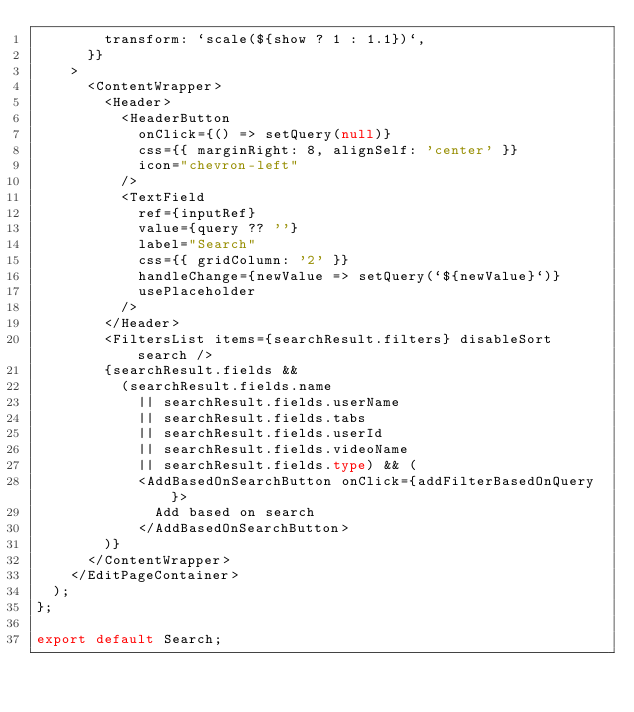<code> <loc_0><loc_0><loc_500><loc_500><_TypeScript_>        transform: `scale(${show ? 1 : 1.1})`,
      }}
    >
      <ContentWrapper>
        <Header>
          <HeaderButton
            onClick={() => setQuery(null)}
            css={{ marginRight: 8, alignSelf: 'center' }}
            icon="chevron-left"
          />
          <TextField
            ref={inputRef}
            value={query ?? ''}
            label="Search"
            css={{ gridColumn: '2' }}
            handleChange={newValue => setQuery(`${newValue}`)}
            usePlaceholder
          />
        </Header>
        <FiltersList items={searchResult.filters} disableSort search />
        {searchResult.fields &&
          (searchResult.fields.name
            || searchResult.fields.userName
            || searchResult.fields.tabs
            || searchResult.fields.userId
            || searchResult.fields.videoName
            || searchResult.fields.type) && (
            <AddBasedOnSearchButton onClick={addFilterBasedOnQuery}>
              Add based on search
            </AddBasedOnSearchButton>
        )}
      </ContentWrapper>
    </EditPageContainer>
  );
};

export default Search;
</code> 